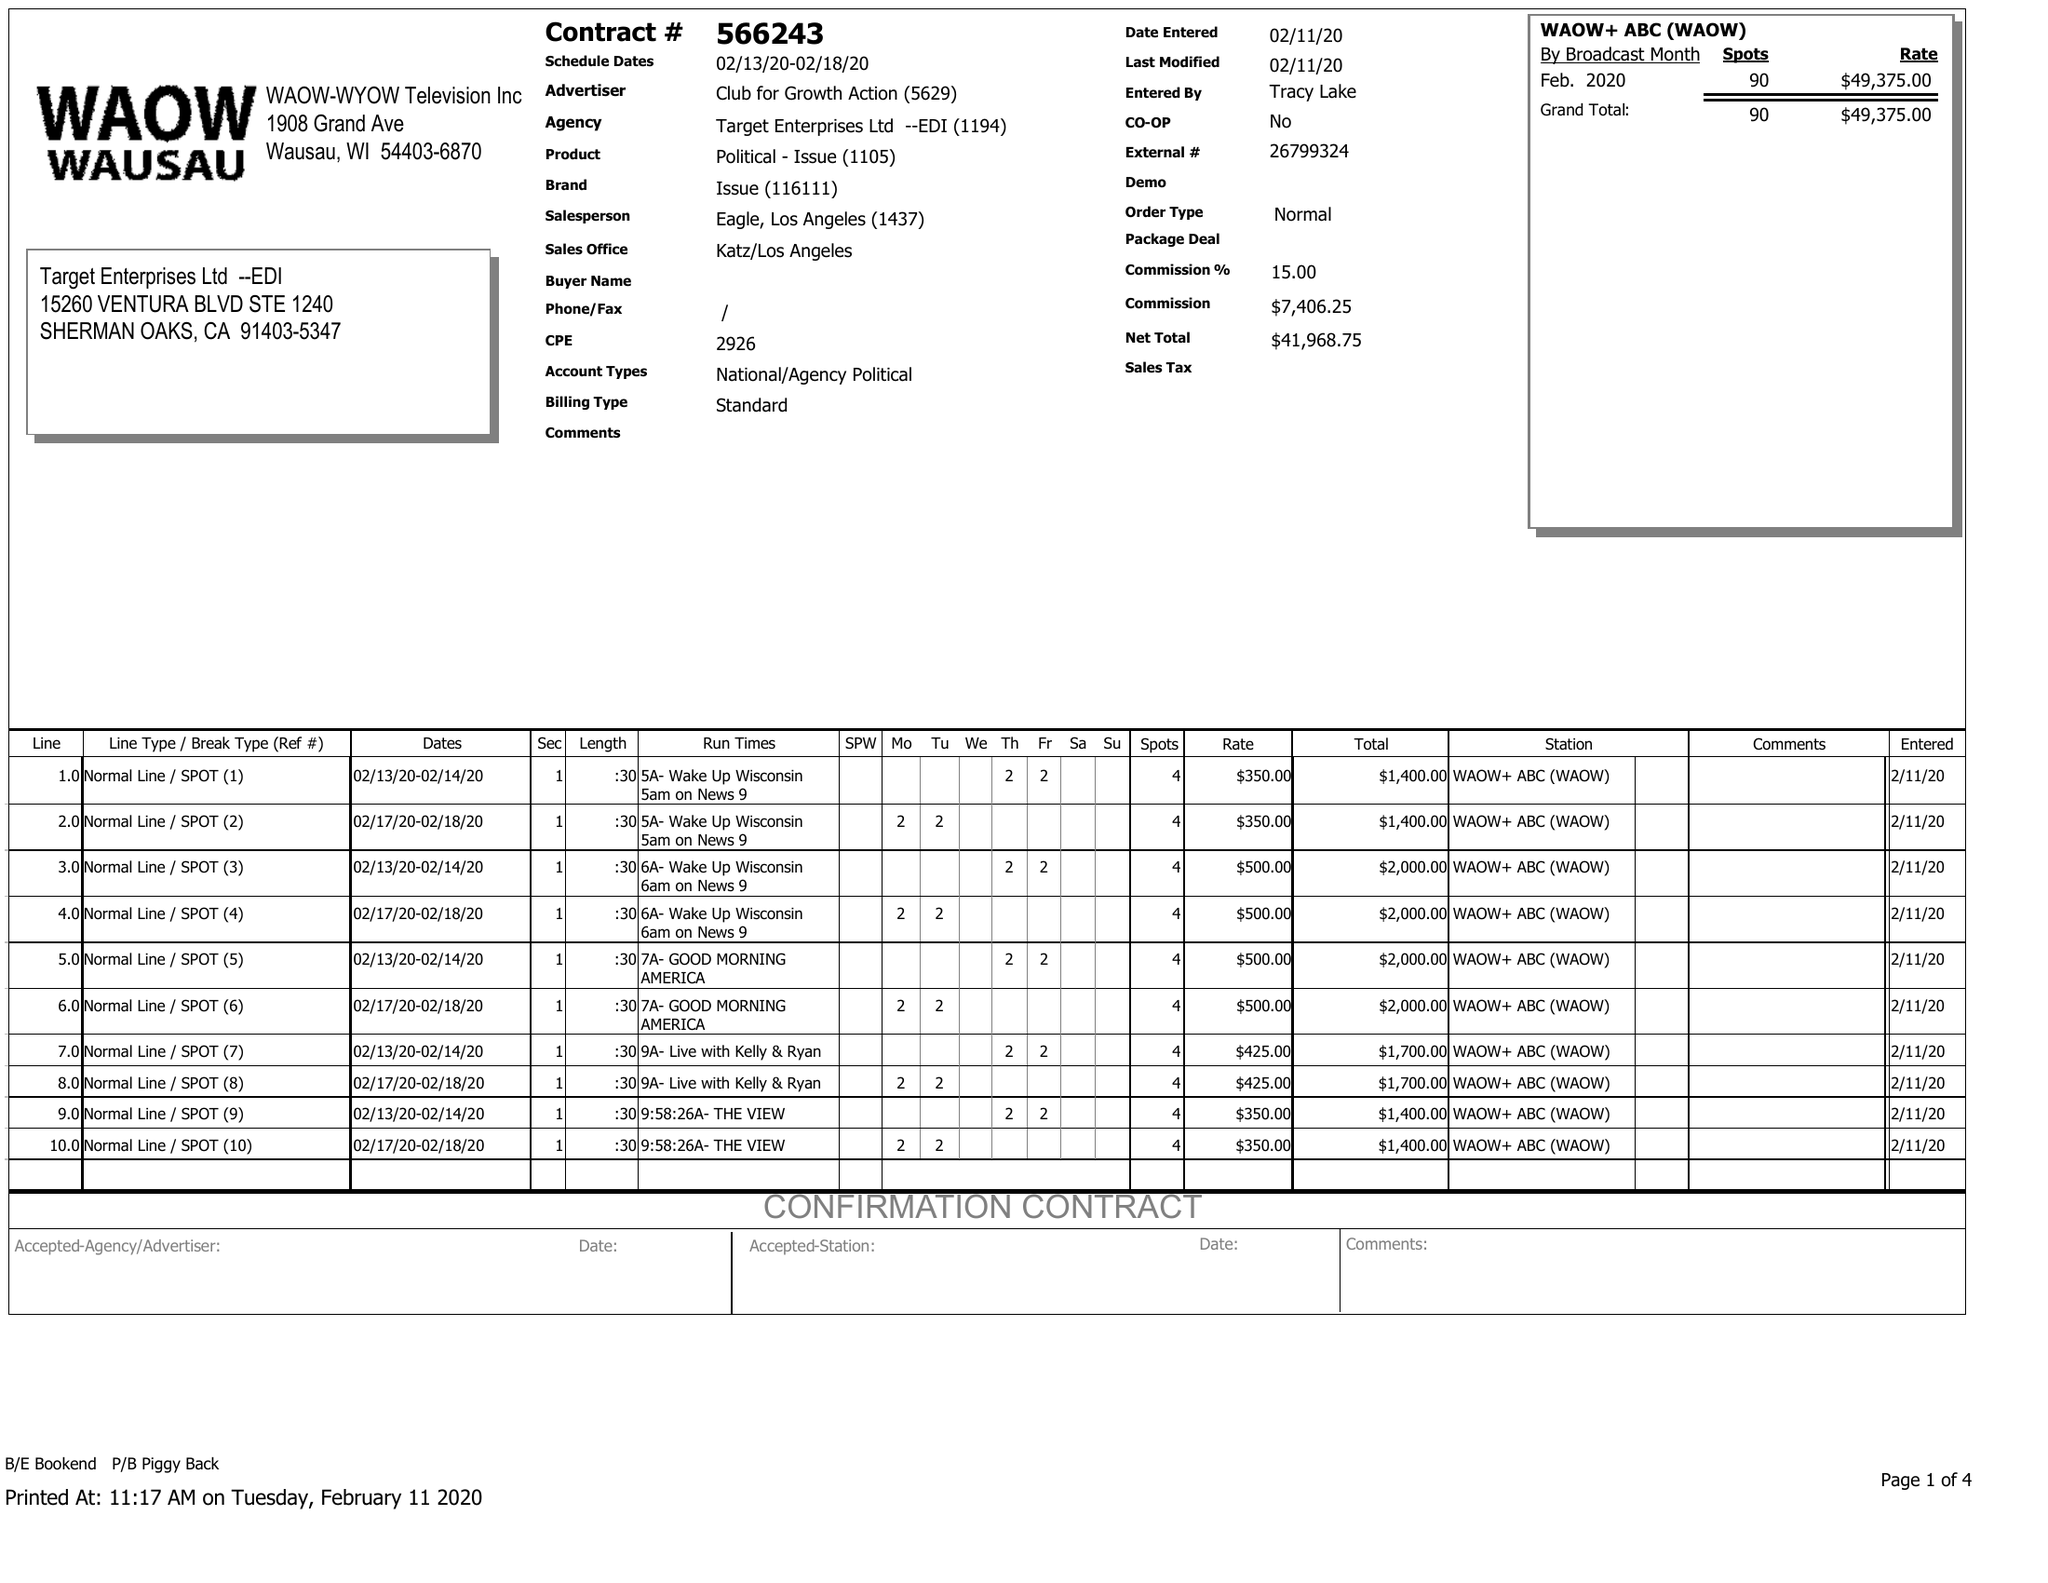What is the value for the advertiser?
Answer the question using a single word or phrase. CLUB FOR GROWTH ACTION 